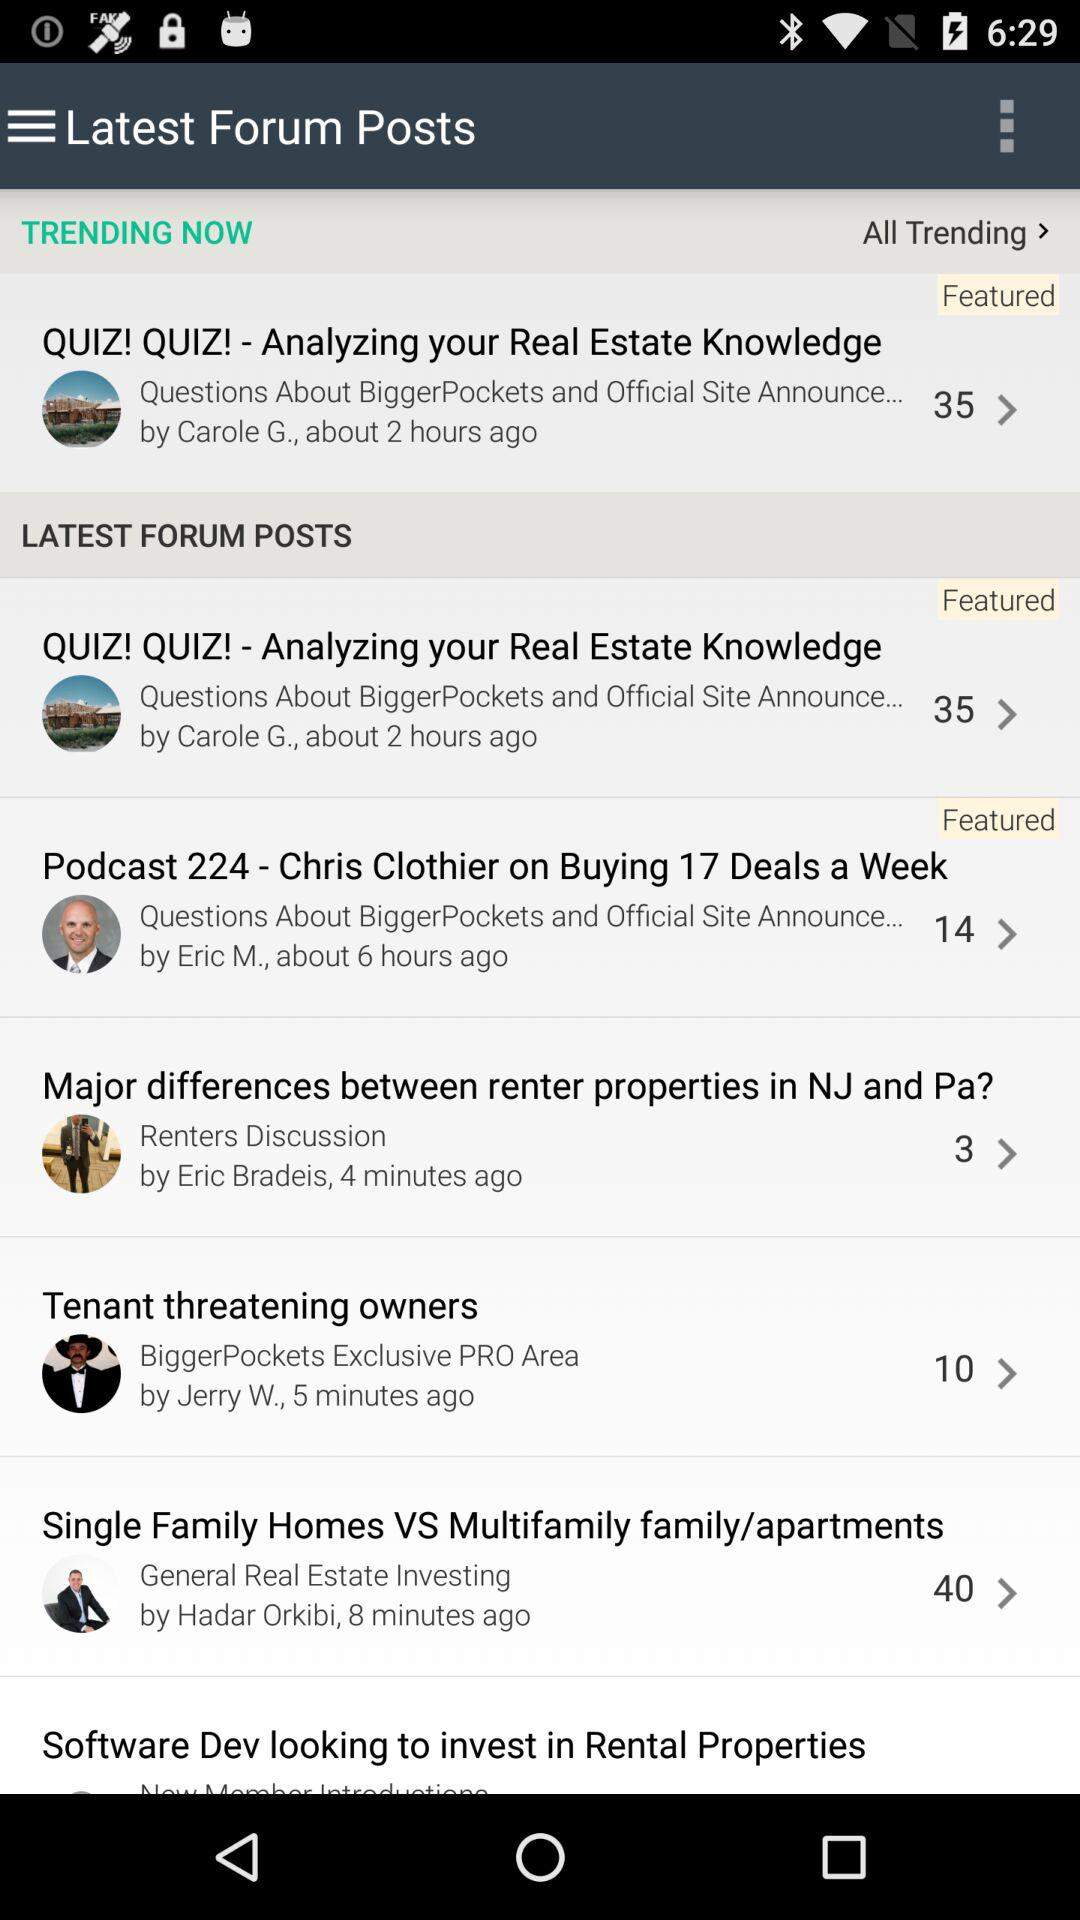Who wrote the post "Software Dev looking to invest in Rental Properties"?
When the provided information is insufficient, respond with <no answer>. <no answer> 